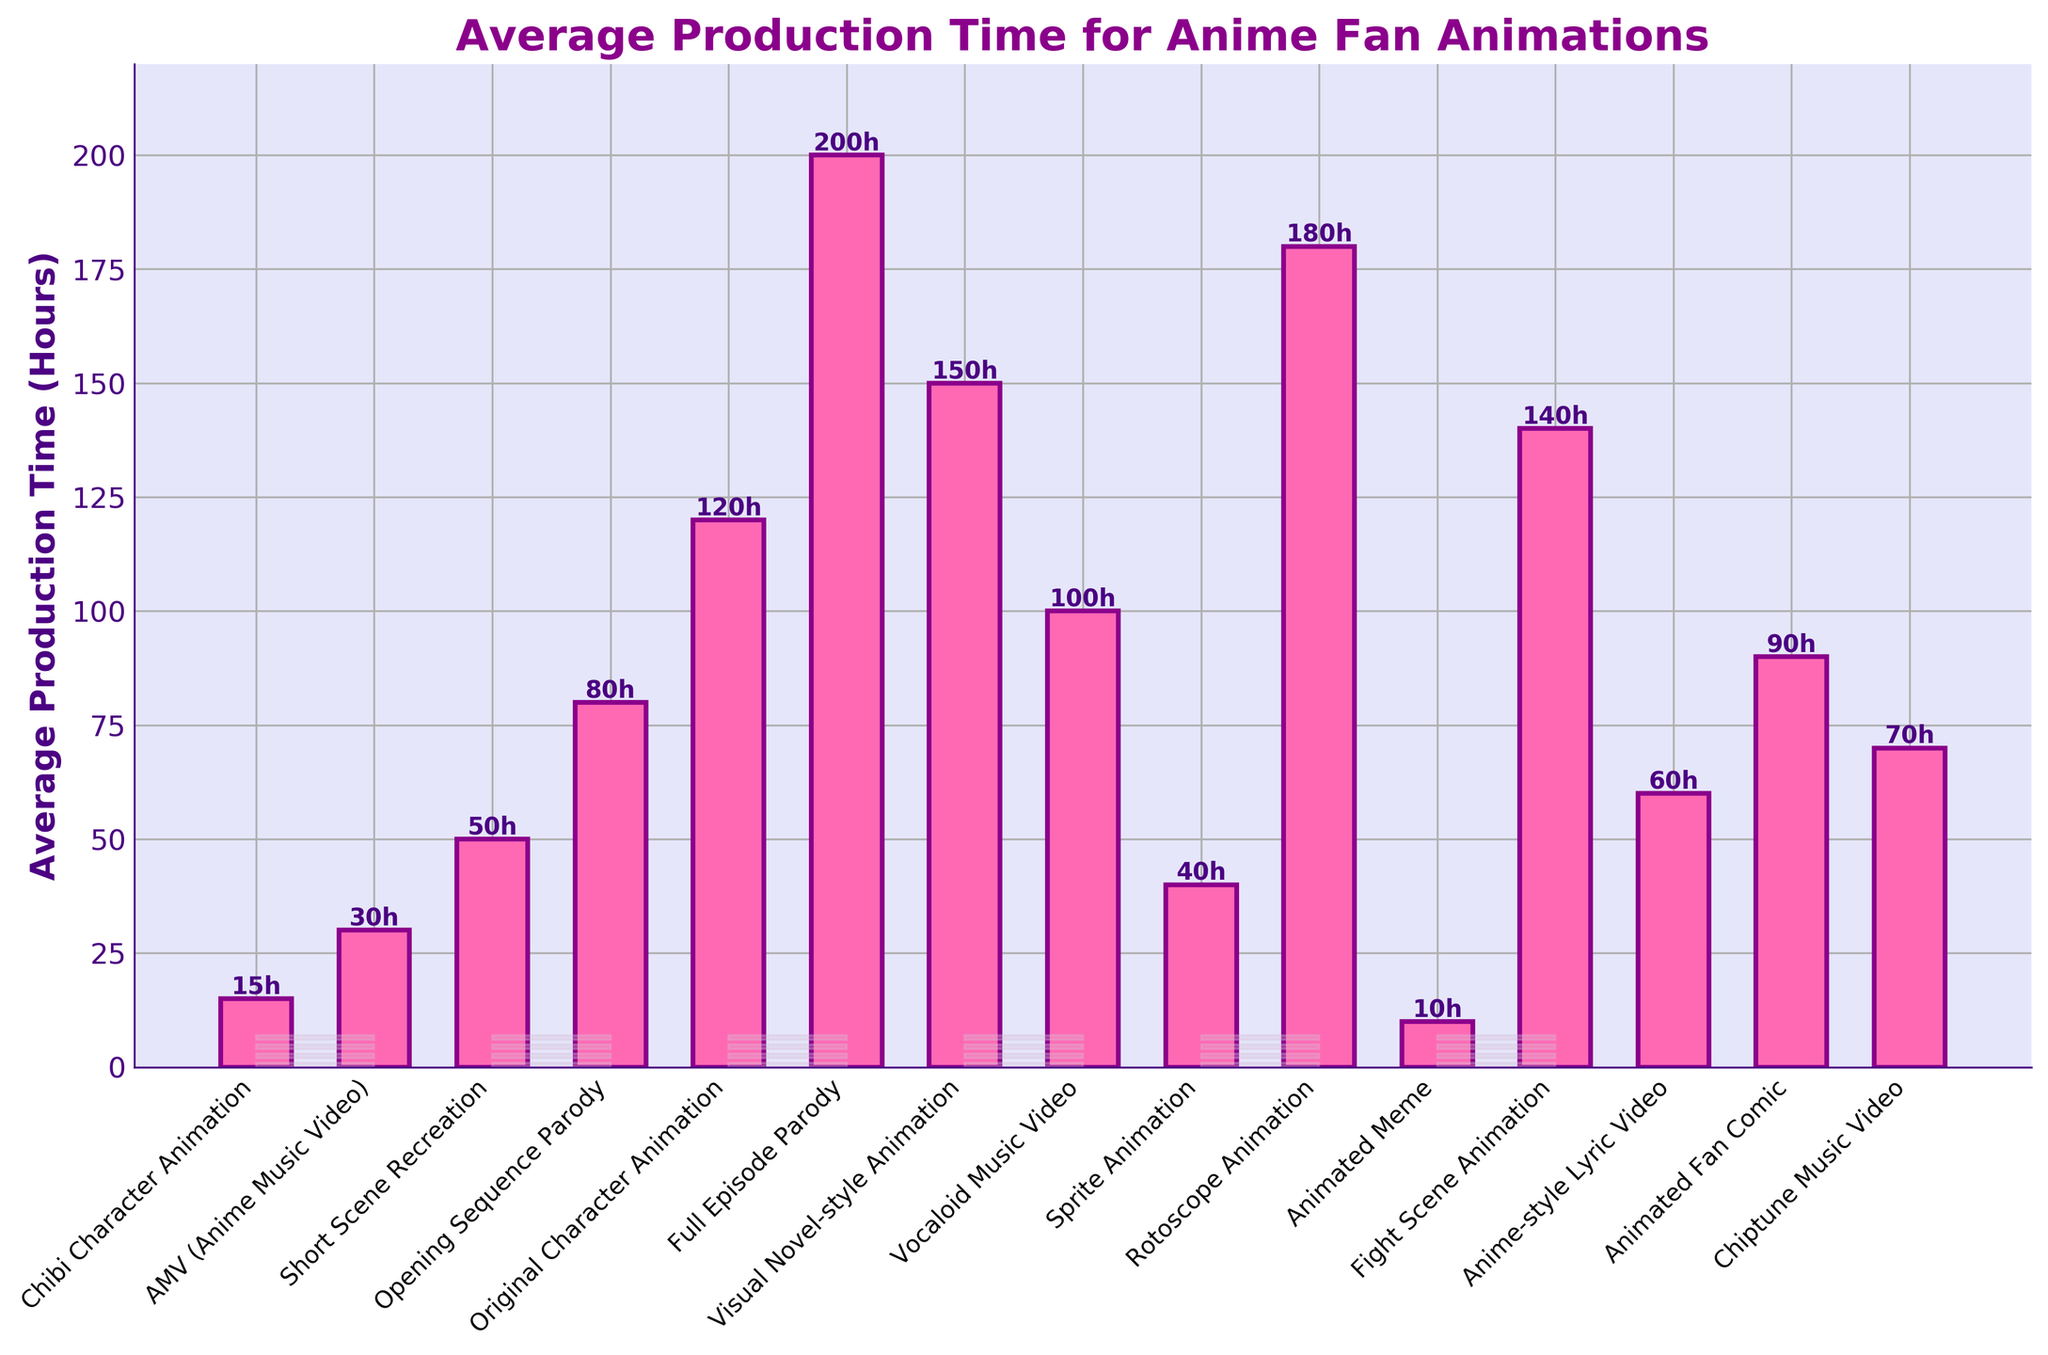Which animation type has the longest average production time? The bar with the highest height represents the longest average production time. We look for the tallest bar and the label associated with it. The tallest bar is labeled "Full Episode Parody."
Answer: Full Episode Parody Which animation type has the shortest average production time? The bar with the shortest height represents the shortest average production time. We look for the shortest bar and the label associated with it. The shortest bar is labeled "Animated Meme."
Answer: Animated Meme What's the average production time for "Vocaloid Music Video"? Find the height of the bar labeled "Vocaloid Music Video." The label shows the bar reaches up to 100 hours.
Answer: 100 hours Which animations have average production times greater than 100 hours? Look at the bars that extend above the 100-hour mark and note their labels. These labels are "Original Character Animation," "Full Episode Parody," "Visual Novel-style Animation," "Rotoscope Animation," and "Fight Scene Animation."
Answer: Original Character Animation, Full Episode Parody, Visual Novel-style Animation, Rotoscope Animation, Fight Scene Animation What is the combined average production time of "Chibi Character Animation" and "AMV (Anime Music Video)"? Add the average production times for "Chibi Character Animation" (15 hours) and "AMV (Anime Music Video)" (30 hours). The combined time is 15 + 30 = 45 hours.
Answer: 45 hours How much longer, on average, does it take to produce an "Original Character Animation" compared to a "Sprite Animation"? Subtract the average production time of "Sprite Animation" (40 hours) from "Original Character Animation" (120 hours). The difference is 120 - 40 = 80 hours.
Answer: 80 hours Which animation type takes more average production time: "Fight Scene Animation" or "Rotoscope Animation"? Compare the heights of the bars labeled "Fight Scene Animation" (140 hours) and "Rotoscope Animation" (180 hours). The bar "Rotoscope Animation" is taller, indicating a longer average production time.
Answer: Rotoscope Animation What is the average production time of the three animation types: "Chiptune Music Video", "Anime-style Lyric Video", and "Animated Fan Comic"? Add the average production times for these three types and divide by three: (70 + 60 + 90) / 3 = 220 / 3 ≈ 73.33 hours.
Answer: ~73.33 hours Are there more animation types with an average production time less than 50 hours or more than 100 hours? Count the bars with average production times less than 50 hours and those more than 100 hours: Less than 50 hours - 4 types ("Chibi Character Animation," "AMV (Anime Music Video)," "Animated Meme," "Sprite Animation"); More than 100 hours - 5 types ("Original Character Animation," "Full Episode Parody," "Visual Novel-style Animation," "Rotoscope Animation," "Fight Scene Animation"). There are more types with average production times more than 100 hours.
Answer: More than 100 hours 